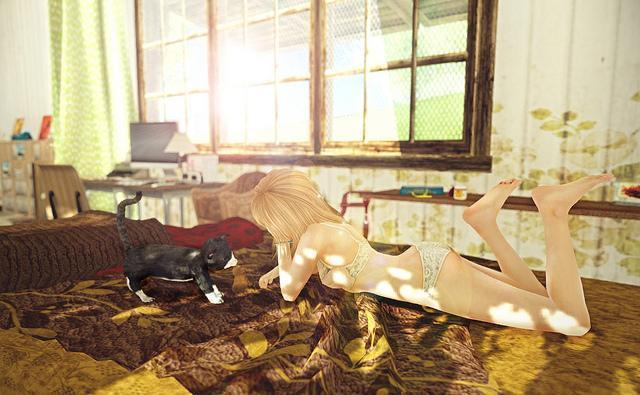How many chairs are there?
Give a very brief answer. 2. How many people can you see?
Give a very brief answer. 1. How many black railroad cars are at the train station?
Give a very brief answer. 0. 